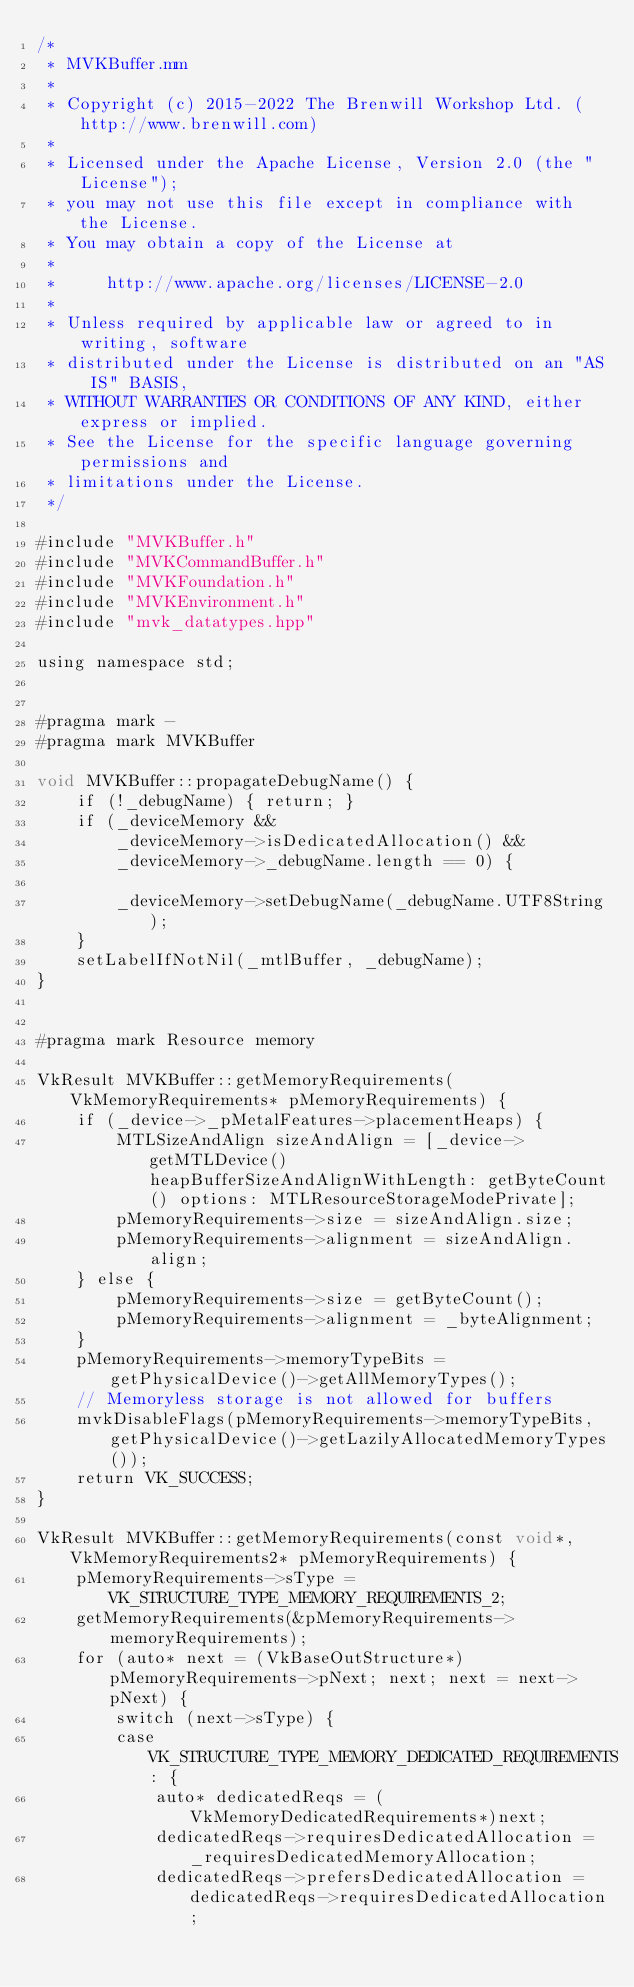Convert code to text. <code><loc_0><loc_0><loc_500><loc_500><_ObjectiveC_>/*
 * MVKBuffer.mm
 *
 * Copyright (c) 2015-2022 The Brenwill Workshop Ltd. (http://www.brenwill.com)
 *
 * Licensed under the Apache License, Version 2.0 (the "License");
 * you may not use this file except in compliance with the License.
 * You may obtain a copy of the License at
 * 
 *     http://www.apache.org/licenses/LICENSE-2.0
 * 
 * Unless required by applicable law or agreed to in writing, software
 * distributed under the License is distributed on an "AS IS" BASIS,
 * WITHOUT WARRANTIES OR CONDITIONS OF ANY KIND, either express or implied.
 * See the License for the specific language governing permissions and
 * limitations under the License.
 */

#include "MVKBuffer.h"
#include "MVKCommandBuffer.h"
#include "MVKFoundation.h"
#include "MVKEnvironment.h"
#include "mvk_datatypes.hpp"

using namespace std;


#pragma mark -
#pragma mark MVKBuffer

void MVKBuffer::propagateDebugName() {
	if (!_debugName) { return; }
	if (_deviceMemory &&
		_deviceMemory->isDedicatedAllocation() &&
		_deviceMemory->_debugName.length == 0) {

		_deviceMemory->setDebugName(_debugName.UTF8String);
	}
	setLabelIfNotNil(_mtlBuffer, _debugName);
}


#pragma mark Resource memory

VkResult MVKBuffer::getMemoryRequirements(VkMemoryRequirements* pMemoryRequirements) {
	if (_device->_pMetalFeatures->placementHeaps) {
		MTLSizeAndAlign sizeAndAlign = [_device->getMTLDevice() heapBufferSizeAndAlignWithLength: getByteCount() options: MTLResourceStorageModePrivate];
		pMemoryRequirements->size = sizeAndAlign.size;
		pMemoryRequirements->alignment = sizeAndAlign.align;
	} else {
		pMemoryRequirements->size = getByteCount();
		pMemoryRequirements->alignment = _byteAlignment;
	}
	pMemoryRequirements->memoryTypeBits = getPhysicalDevice()->getAllMemoryTypes();
	// Memoryless storage is not allowed for buffers
	mvkDisableFlags(pMemoryRequirements->memoryTypeBits, getPhysicalDevice()->getLazilyAllocatedMemoryTypes());
	return VK_SUCCESS;
}

VkResult MVKBuffer::getMemoryRequirements(const void*, VkMemoryRequirements2* pMemoryRequirements) {
	pMemoryRequirements->sType = VK_STRUCTURE_TYPE_MEMORY_REQUIREMENTS_2;
	getMemoryRequirements(&pMemoryRequirements->memoryRequirements);
	for (auto* next = (VkBaseOutStructure*)pMemoryRequirements->pNext; next; next = next->pNext) {
		switch (next->sType) {
		case VK_STRUCTURE_TYPE_MEMORY_DEDICATED_REQUIREMENTS: {
			auto* dedicatedReqs = (VkMemoryDedicatedRequirements*)next;
			dedicatedReqs->requiresDedicatedAllocation = _requiresDedicatedMemoryAllocation;
			dedicatedReqs->prefersDedicatedAllocation = dedicatedReqs->requiresDedicatedAllocation;</code> 